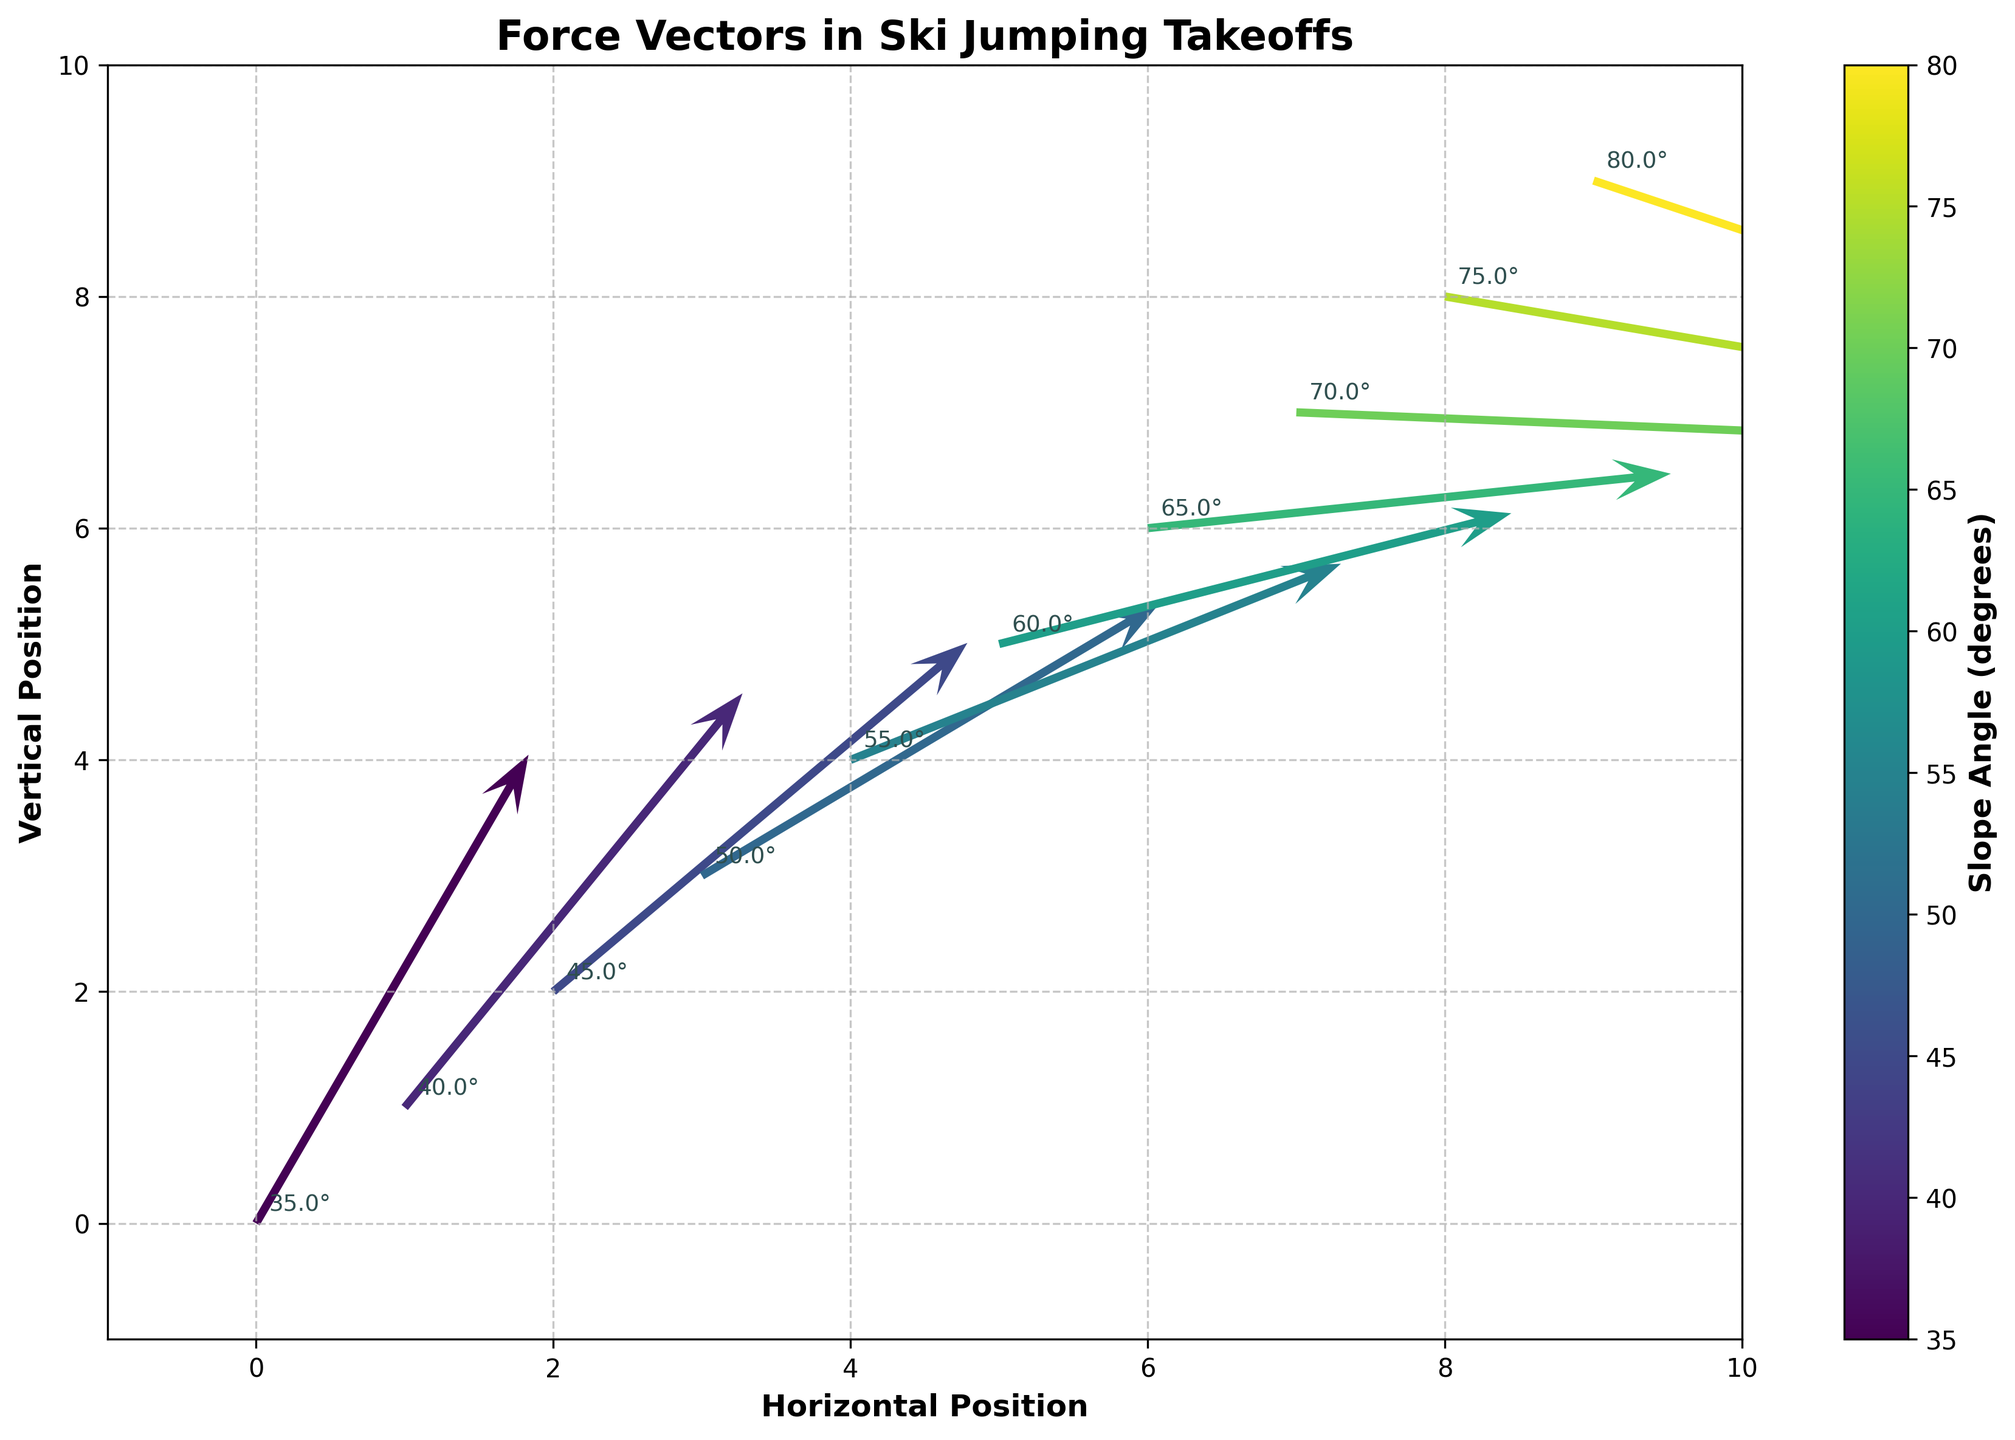What is the title of the plot? The title of the plot is located at the top center and conveys the main topic of the visual representation. By looking at the figure, we see the title is "Force Vectors in Ski Jumping Takeoffs."
Answer: Force Vectors in Ski Jumping Takeoffs What are the labels of the X and Y axes? The labels of the axes are found along each axis line. On the horizontal axis, the label reads "Horizontal Position," and on the vertical axis, the label reads "Vertical Position."
Answer: Horizontal Position (X) and Vertical Position (Y) How many data points (arrows) are displayed in the quiver plot? The number of arrows corresponds to the number of data points provided. By counting them in the plot, we can see there are ten arrows.
Answer: 10 Which data point shows the highest vertical component (V) of the force vector? To identify the highest vertical component of the force vector, we compare the V values of all arrows. The point with coordinates (0,0) has a V value of 4.3, which is the highest.
Answer: (0,0) At which horizontal position (X) does the force vector start to negatively impact the takeoff? To determine where the vertical component (V) becomes negative, we look for the first arrow where V is less than 0. This occurs at X=7, where V is -0.2.
Answer: X=7 What is the average slope angle across all data points? To find the average slope angle, we sum the slope values (35 + 40 + 45 + 50 + 55 + 60 + 65 + 70 + 75 + 80) and divide by the number of data points (10). The calculation is (575/10).
Answer: 57.5° What does the color of the arrows represent in the plot? The color of the arrows indicates the slope angles within the dataset, as shown by the color gradient in the color bar.
Answer: Slope Angle Which force vector has the smallest horizontal component (U), and what is its value? The horizontal component (U) of each force vector can be matched to its corresponding arrow. The smallest U value is 2.5 at coordinates (0,0).
Answer: (0,0), U=2.5 How does the direction of the force vectors change as the slope angle increases? Observing the arrows, initially, the vectors point upwards and slightly right. As the slope angle increases, the vectors' vertical components reduce and eventually point downwards at the higher angles.
Answer: Upwards to Downwards Compare the force vector magnitudes at X=2 and X=5 by their length. Which is larger? The magnitude can be estimated by the length of the arrows. Vector at X=2 (U=3.8, V=3.2) is compared visually to X=5 (U=4.7, V=1.2). The longer arrow, indicating the larger magnitude, is at X=5.
Answer: X=5 